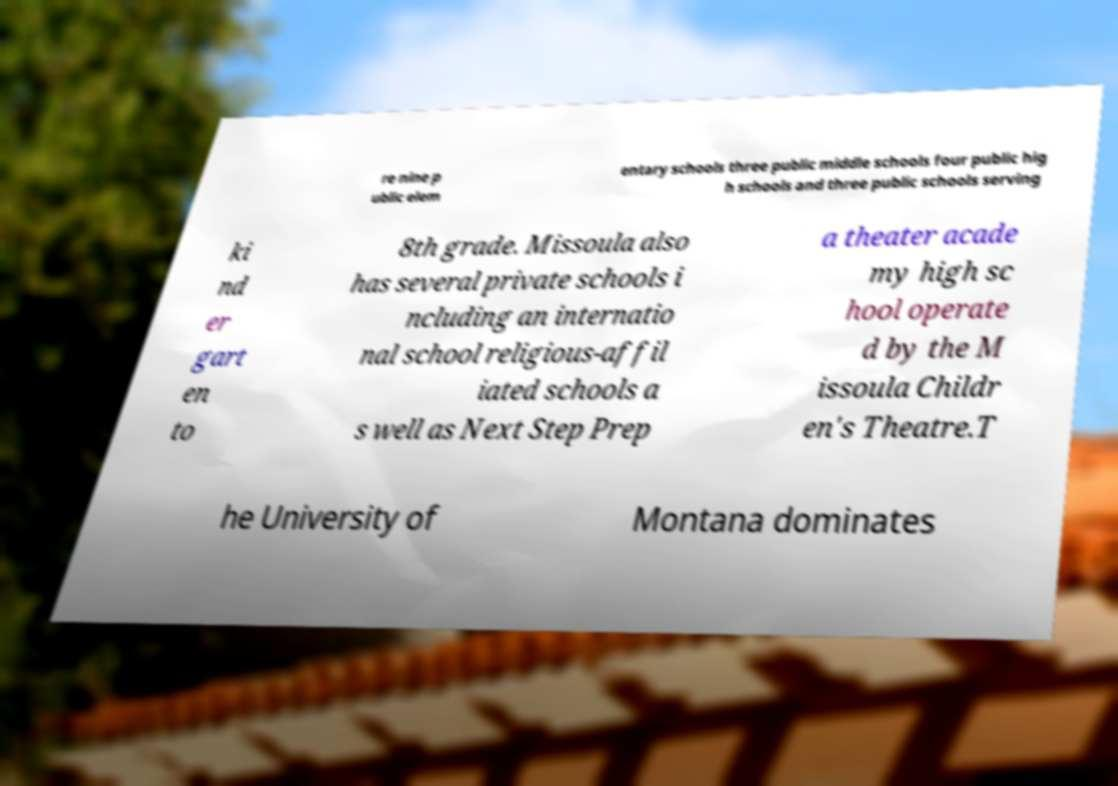Please identify and transcribe the text found in this image. re nine p ublic elem entary schools three public middle schools four public hig h schools and three public schools serving ki nd er gart en to 8th grade. Missoula also has several private schools i ncluding an internatio nal school religious-affil iated schools a s well as Next Step Prep a theater acade my high sc hool operate d by the M issoula Childr en's Theatre.T he University of Montana dominates 